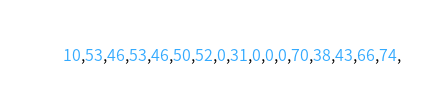Convert code to text. <code><loc_0><loc_0><loc_500><loc_500><_Scala_>      10,53,46,53,46,50,52,0,31,0,0,0,70,38,43,66,74,</code> 